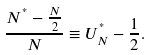Convert formula to latex. <formula><loc_0><loc_0><loc_500><loc_500>\frac { N ^ { ^ { * } } - \frac { N } { 2 } } { N } \equiv U ^ { ^ { * } } _ { N } - \frac { 1 } { 2 } .</formula> 